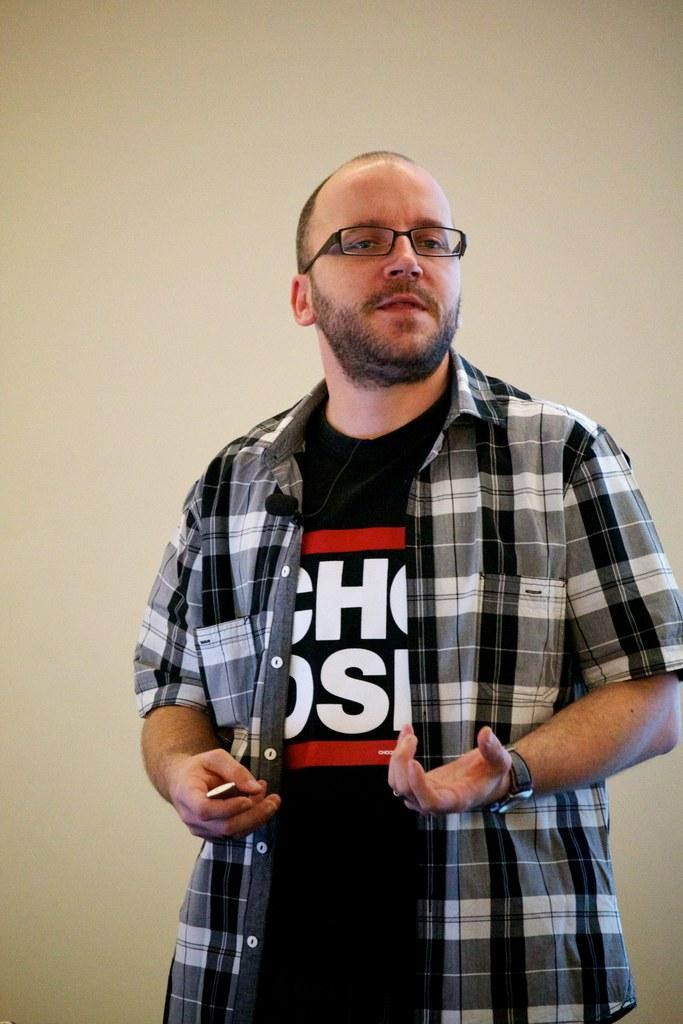What is the man in the image doing? The man is standing in the image. What accessories is the man wearing? The man is wearing a watch and spectacles. What is attached to the man's shirt? There is a mic attached to the man's shirt. What can be seen in the background of the image? There is a wall in the background of the image. What type of steam is coming out of the man's ears in the image? There is no steam coming out of the man's ears in the image; it is not present. 